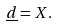<formula> <loc_0><loc_0><loc_500><loc_500>\underline { d } = X .</formula> 